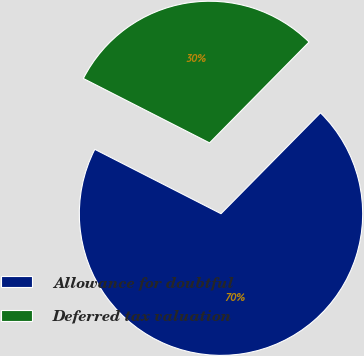Convert chart to OTSL. <chart><loc_0><loc_0><loc_500><loc_500><pie_chart><fcel>Allowance for doubtful<fcel>Deferred tax valuation<nl><fcel>70.12%<fcel>29.88%<nl></chart> 